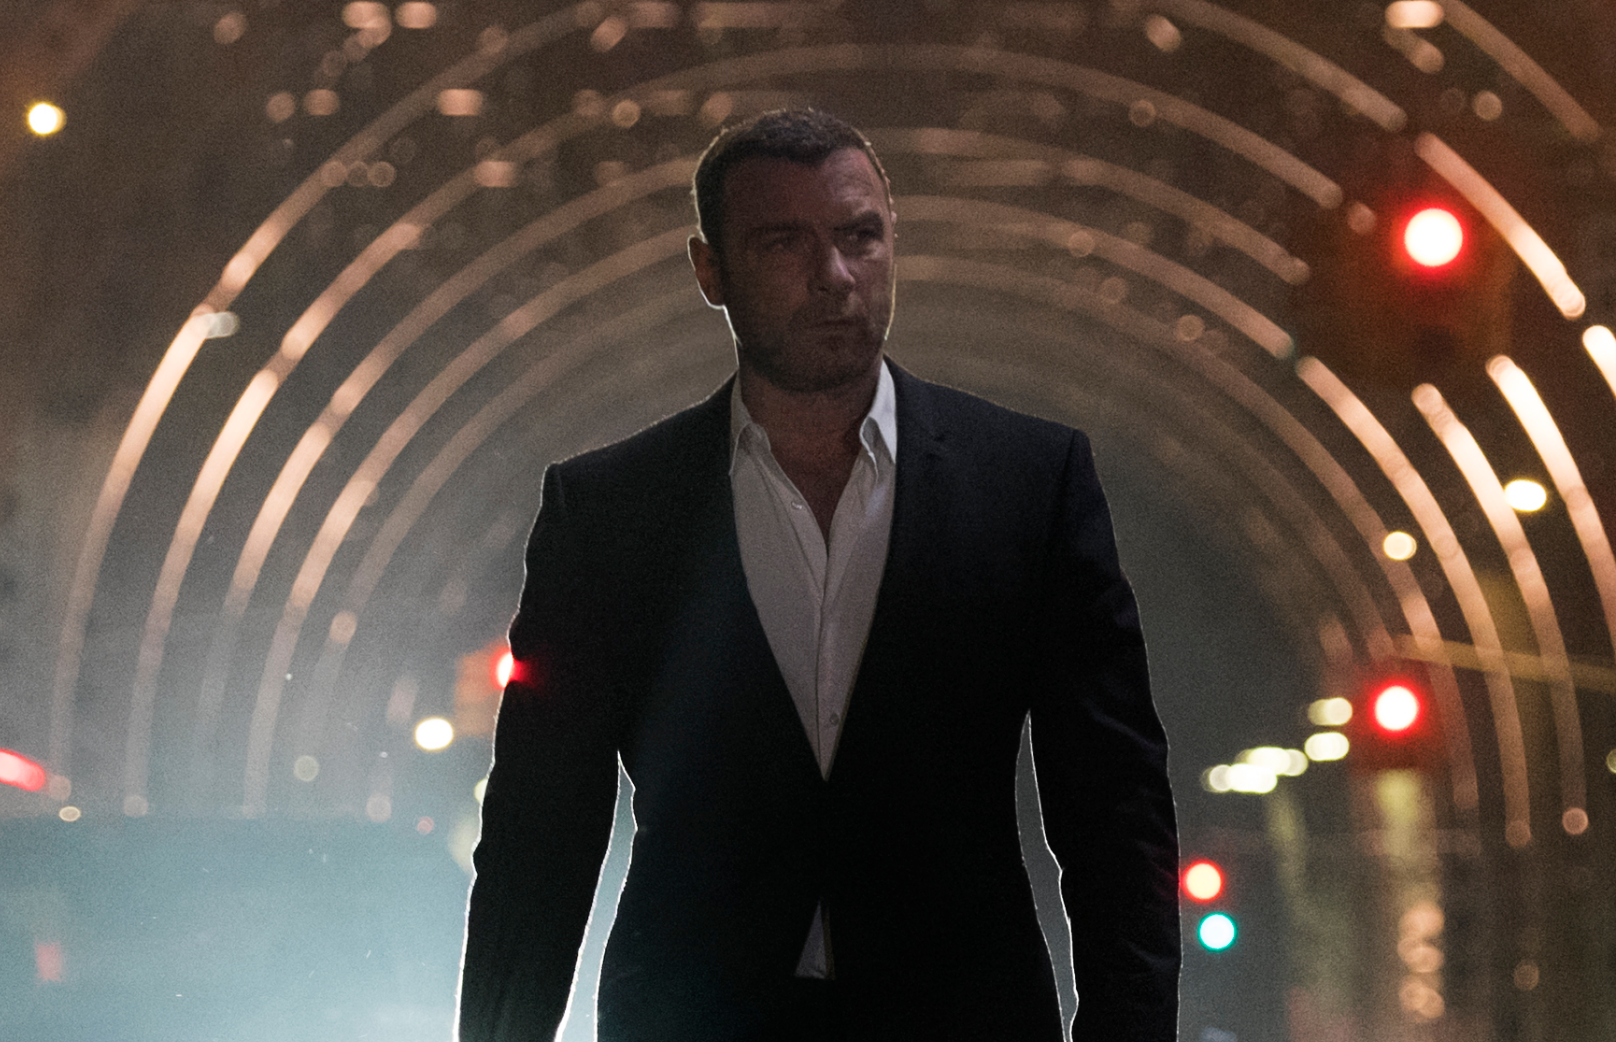What details in this picture suggest it could be from a film noir? The image presents a classic noir ambiance, with its night-time setting, stark lighting contrasts creating deep shadows, and an urban, perhaps even a slightly ominous background. Additionally, the subject's formal, dark attire and serious demeanor are reminiscent of the iconic film noir private detective or antihero archetype. 